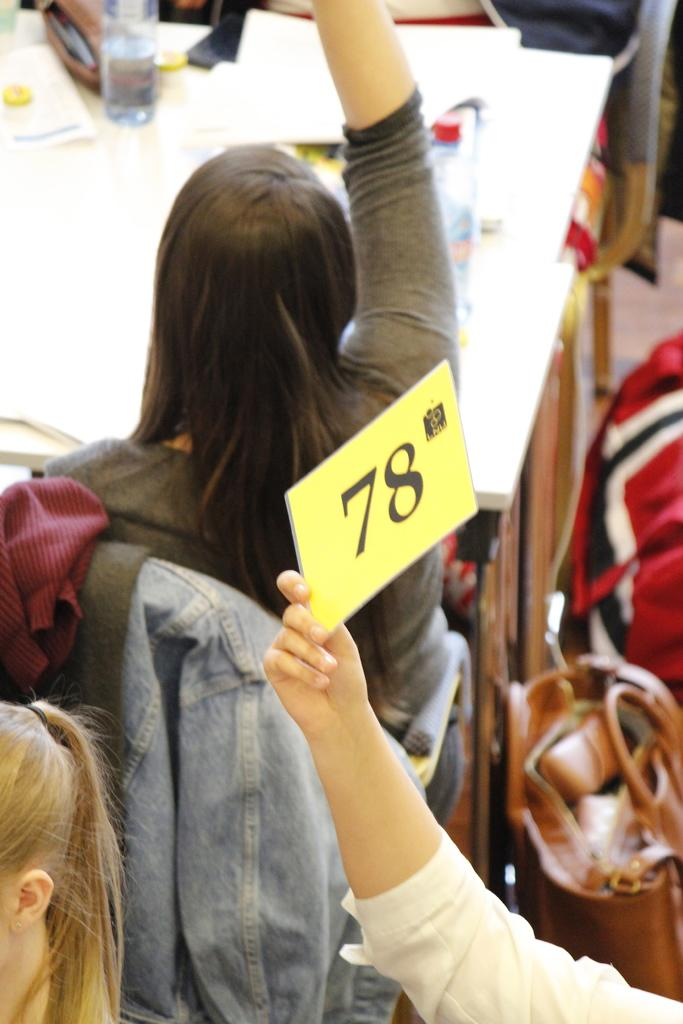What type of furniture is present in the image? There is a table in the image. What can be seen on the table? There are bottles in the image. Can you describe the people in the image? There are people in the image. What other objects are present in the image? There are other objects in the image. What is the person's hand doing on the right side of the image? There is a person's hand holding a board on the right side of the image. What type of hill can be seen in the image? There is no hill present in the image. What is the flesh doing in the image? There is no flesh present in the image. 